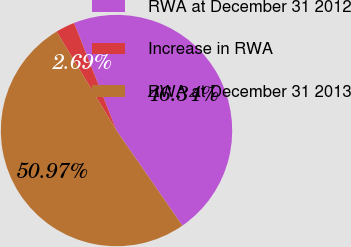Convert chart to OTSL. <chart><loc_0><loc_0><loc_500><loc_500><pie_chart><fcel>RWA at December 31 2012<fcel>Increase in RWA<fcel>RWA at December 31 2013<nl><fcel>46.34%<fcel>2.69%<fcel>50.97%<nl></chart> 